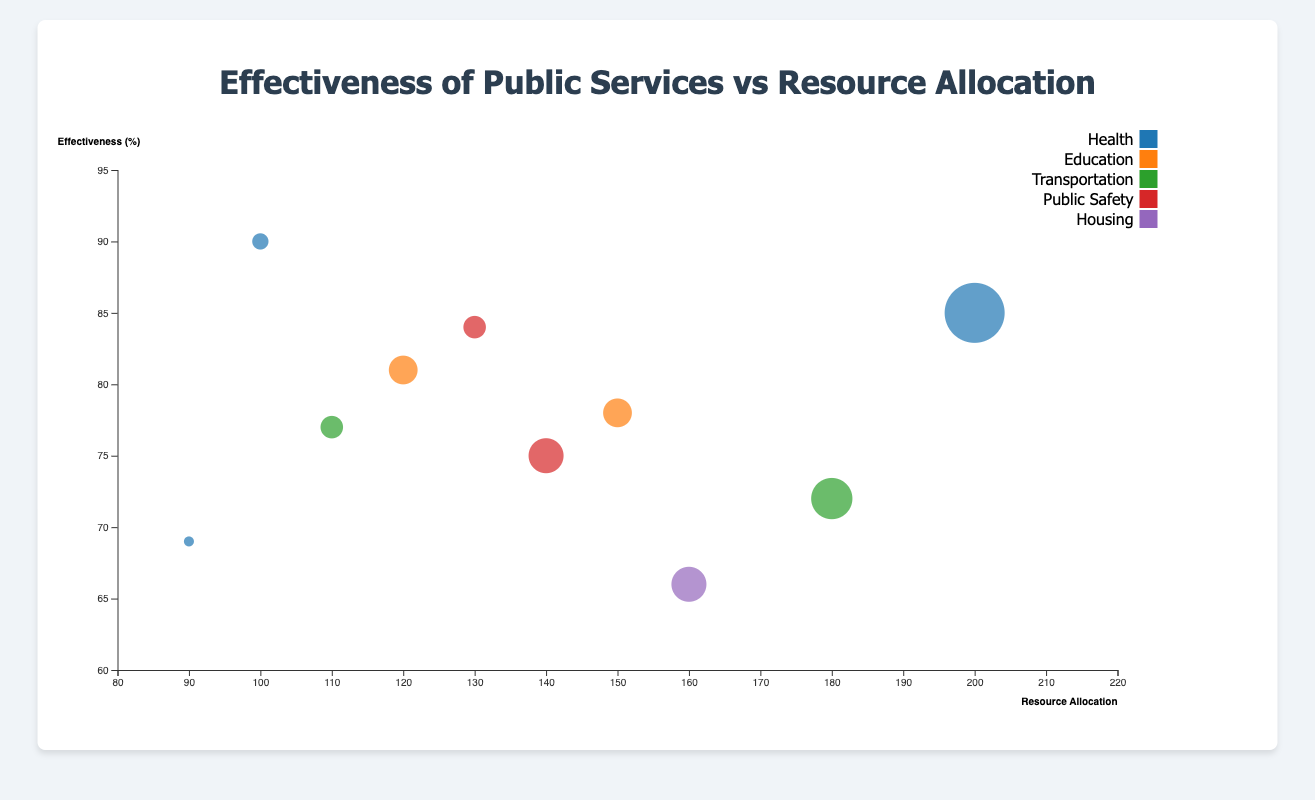What is the title of the chart? The title is displayed at the top center of the chart. It reads "Effectiveness of Public Services vs Resource Allocation".
Answer: "Effectiveness of Public Services vs Resource Allocation" Which department has the highest effectiveness for a public service? By examining the y-axis which represents Effectiveness, the highest value is 90%, associated with the Health department for the "Vaccination Programs" service.
Answer: Health What is the effectiveness of the "Public Transit" service? Find the bubble labeled "Public Transit" and refer to its y-coordinate position on the axis representing Effectiveness. It is 72%.
Answer: 72% How many public services have an effectiveness over 80%? By checking the y-axis positions and looking for bubbles above the 80% line: Health - "Emergency Response" (85%), Health - "Vaccination Programs" (90%), Public Safety - "Fire Services" (84%), Education - "Higher Education" (81%). There are four bubbles in total.
Answer: 4 Which service received the most resources? Examine the x-axis which represents Resource Allocation. The furthest bubble to the right denotes the highest resource allocation, which is the Health department's "Emergency Response" with 200 units.
Answer: Emergency Response Compare the effectiveness of "Primary School" and "Higher Education". Which one is higher and by how much? Locate both bubbles on the y-axis: "Primary School" is at 78% and "Higher Education" is at 81%. Subtract 78 from 81 to find the difference.
Answer: Higher Education by 3% Which service from the "Transportation" department has the lower effectiveness? Identify the bubbles belonging to the Transportation department. "Public Transit" has an effectiveness of 72% and "Road Maintenance" has 77%. Hence, "Public Transit" is lower.
Answer: Public Transit What is the service with the smallest bubble size? Examine the bubbles and their sizes where the smallest bubble size is 7, associated with "Mental Health Services" in the Health department.
Answer: Mental Health Services Which public services have the same bubble size? Check for bubbles with identical sizes: "Primary School" (10), "Higher Education" (10), and "Affordable Housing" (11), "Police Services" (11).
Answer: "Primary School" and "Higher Education"; "Affordable Housing" and "Police Services" 